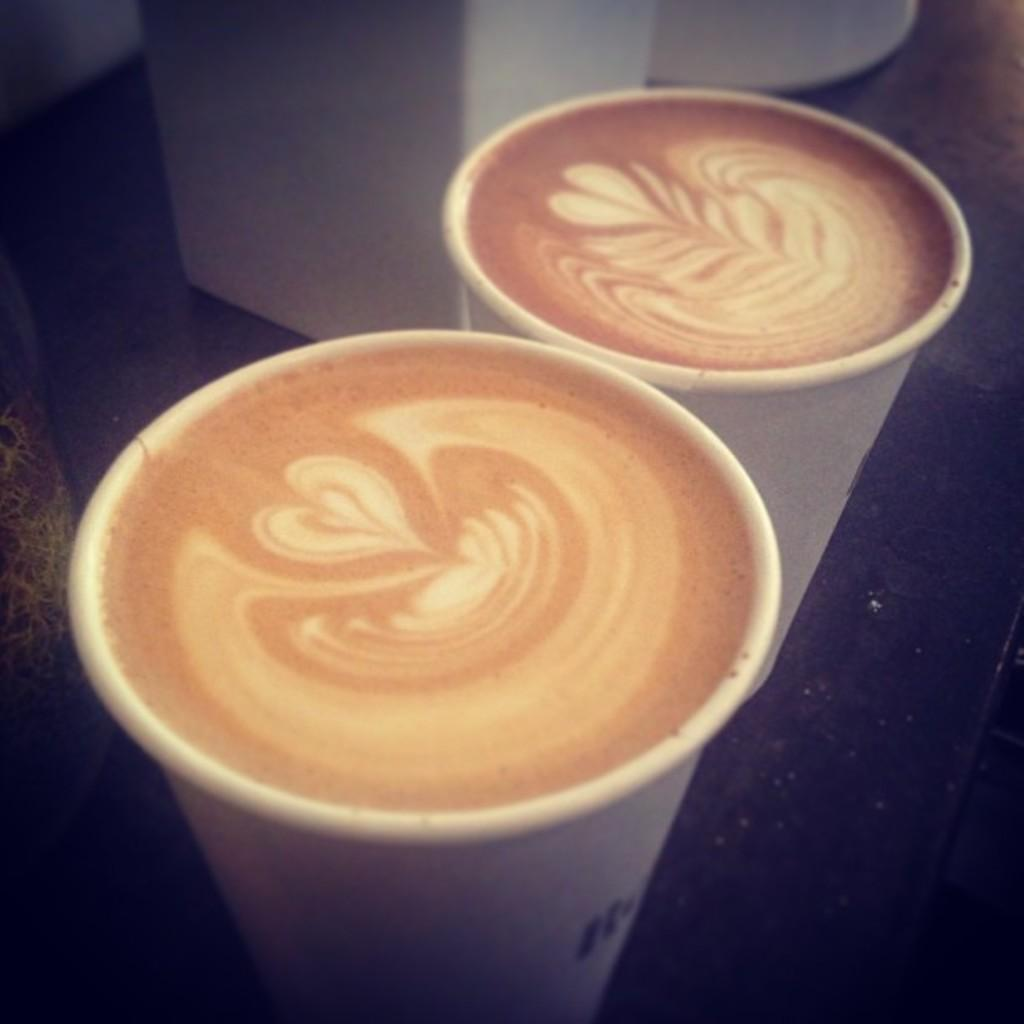What is in the cup that is visible in the image? The cup contains coffee. Can you describe the contents of the cup in more detail? The coffee in the cup is likely hot and possibly flavored with milk or sugar. What historical event is depicted in the image? There is no historical event depicted in the image; it simply shows a cup containing coffee. 